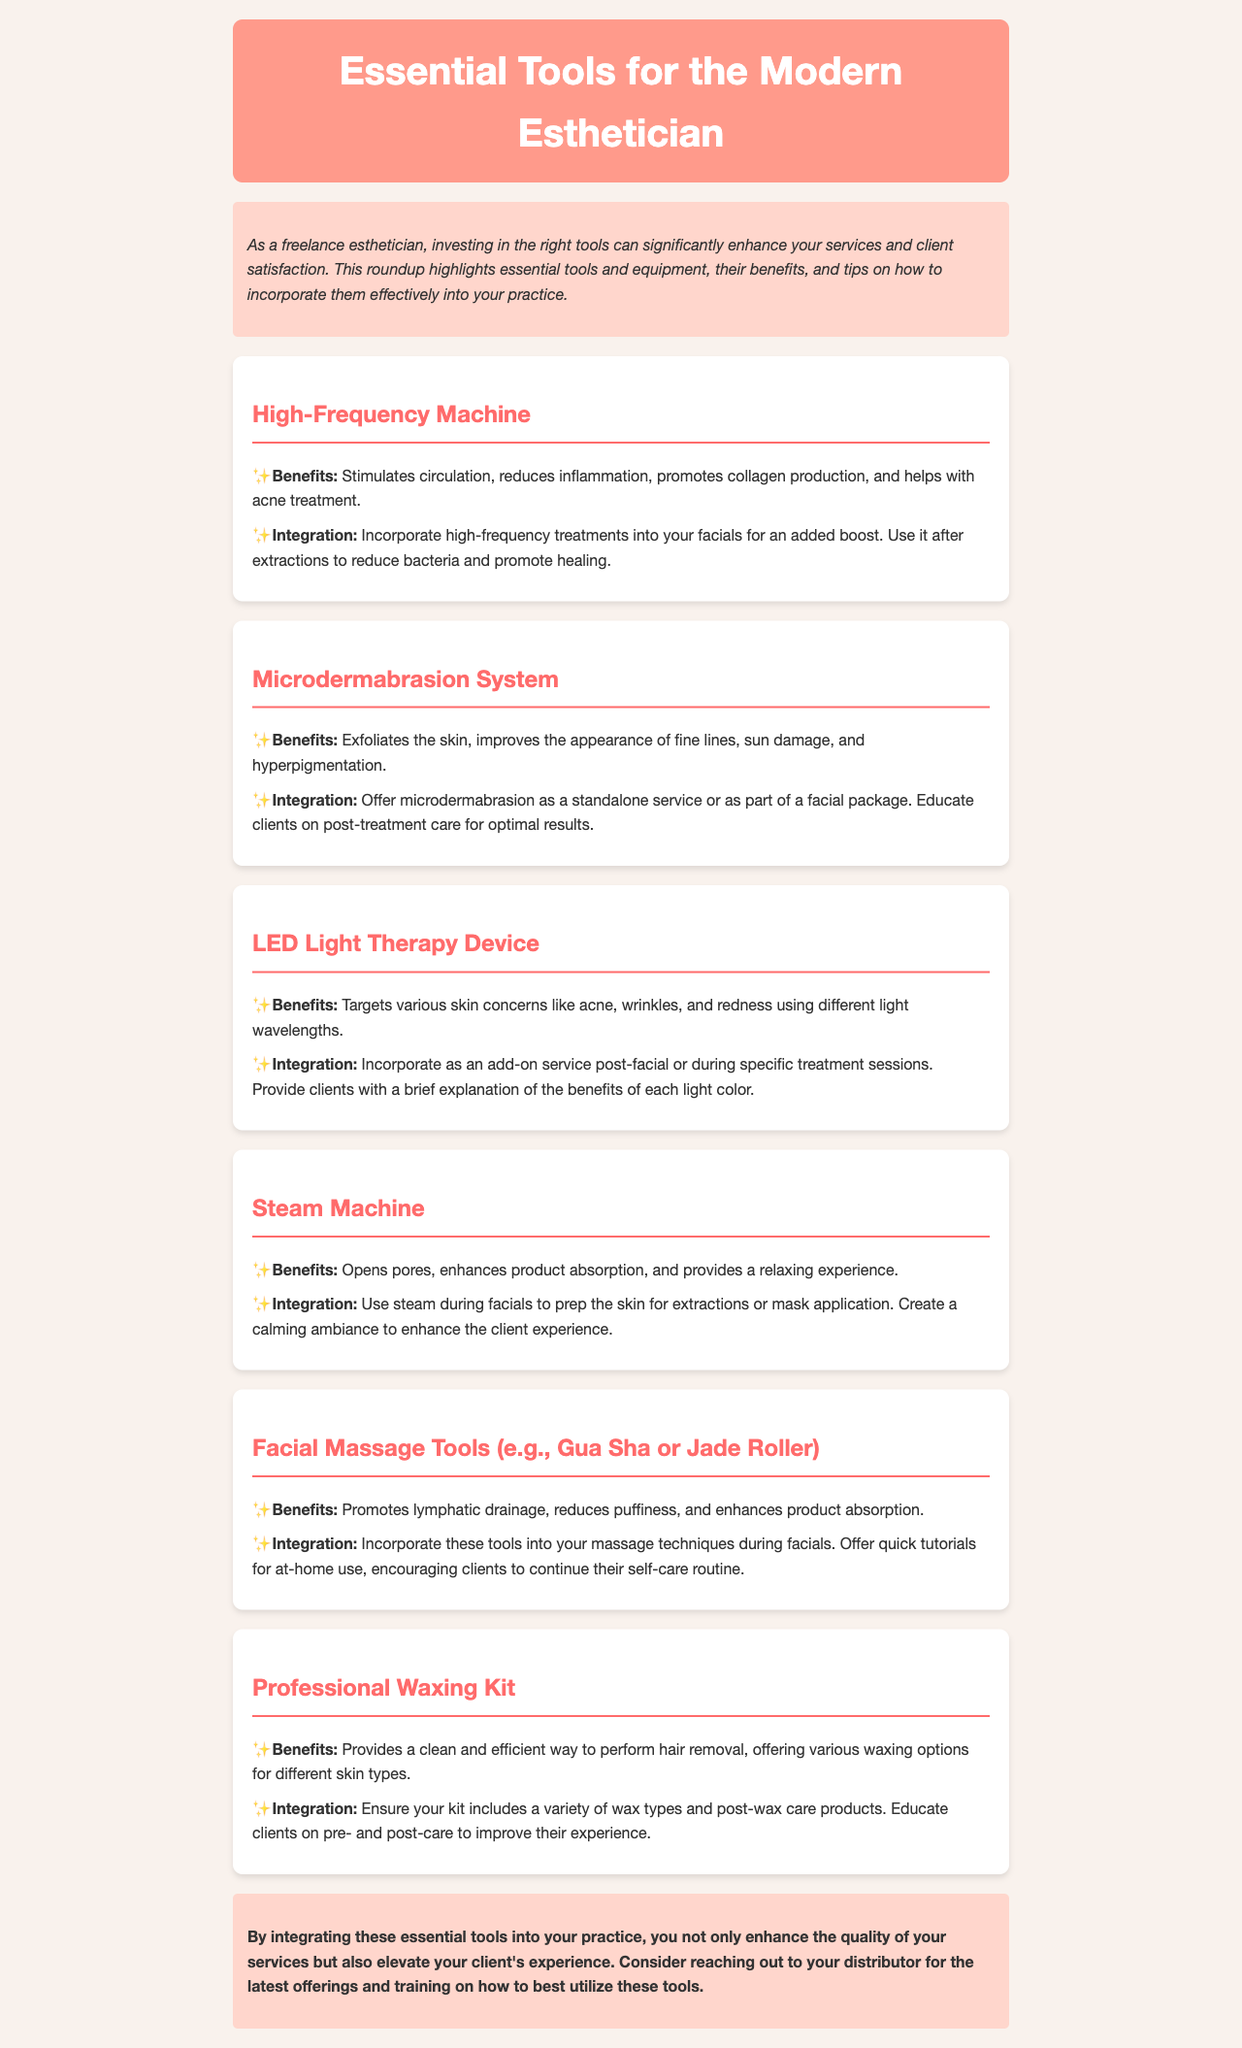What is the title of the newsletter? The title of the newsletter is indicated at the top of the document, stating "Essential Tools for the Modern Esthetician."
Answer: Essential Tools for the Modern Esthetician How many tools are listed in the document? The document enumerates a total of six essential tools for estheticians in the sections provided.
Answer: Six What tool is suggested to stimulate circulation? The High-Frequency Machine is noted for its benefits including stimulating circulation.
Answer: High-Frequency Machine What is a benefit of the Microdermabrasion System? One specified benefit of the Microdermabrasion System is that it improves the appearance of fine lines.
Answer: Improves the appearance of fine lines Which tool is recommended for lymphatic drainage? The Facial Massage Tools, such as Gua Sha or Jade Roller, are highlighted for promoting lymphatic drainage.
Answer: Facial Massage Tools What is a suggested integration for the Steam Machine? The integration suggestion for the Steam Machine is to use it during facials to prep the skin.
Answer: Use it during facials What does the conclusion of the newsletter suggest reaching out for? The conclusion of the newsletter suggests reaching out to the distributor for the latest offerings and training.
Answer: The latest offerings and training 